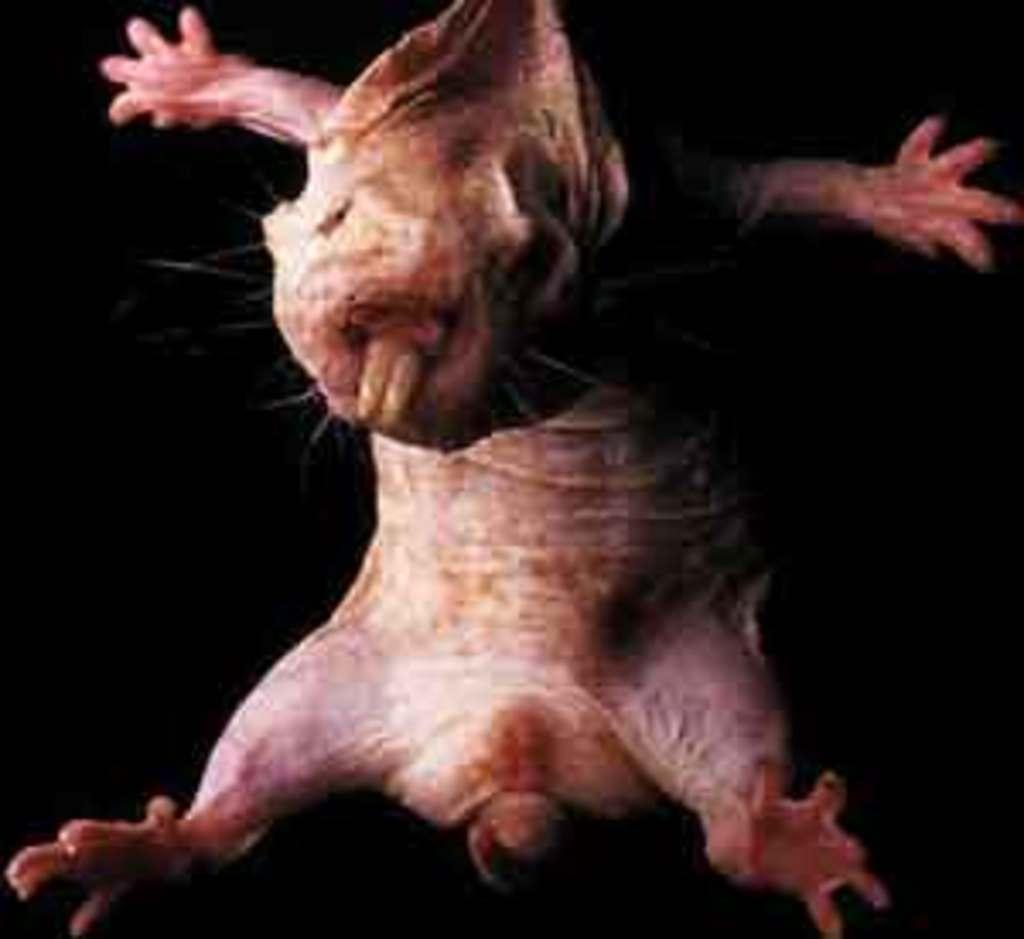What type of animal is present in the image? There is a pig in the image. What effect does the pig have on the edge of the image? There is no mention of an edge or any effect in the image, as it only features a pig. 